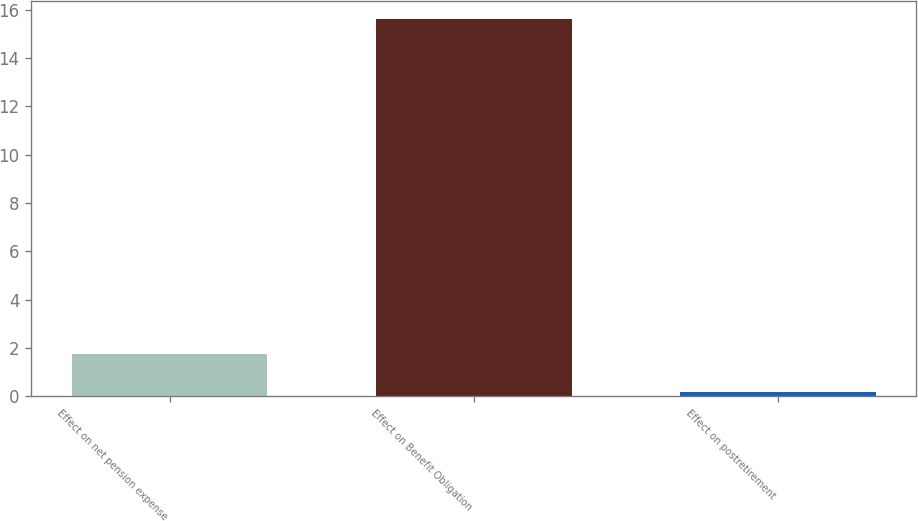Convert chart. <chart><loc_0><loc_0><loc_500><loc_500><bar_chart><fcel>Effect on net pension expense<fcel>Effect on Benefit Obligation<fcel>Effect on postretirement<nl><fcel>1.74<fcel>15.6<fcel>0.2<nl></chart> 